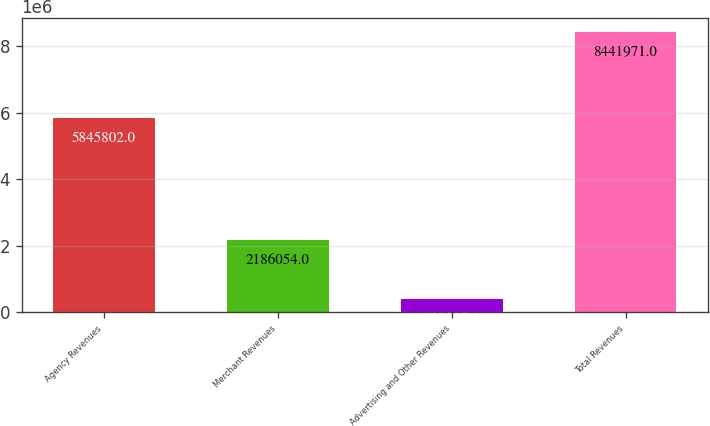<chart> <loc_0><loc_0><loc_500><loc_500><bar_chart><fcel>Agency Revenues<fcel>Merchant Revenues<fcel>Advertising and Other Revenues<fcel>Total Revenues<nl><fcel>5.8458e+06<fcel>2.18605e+06<fcel>410115<fcel>8.44197e+06<nl></chart> 